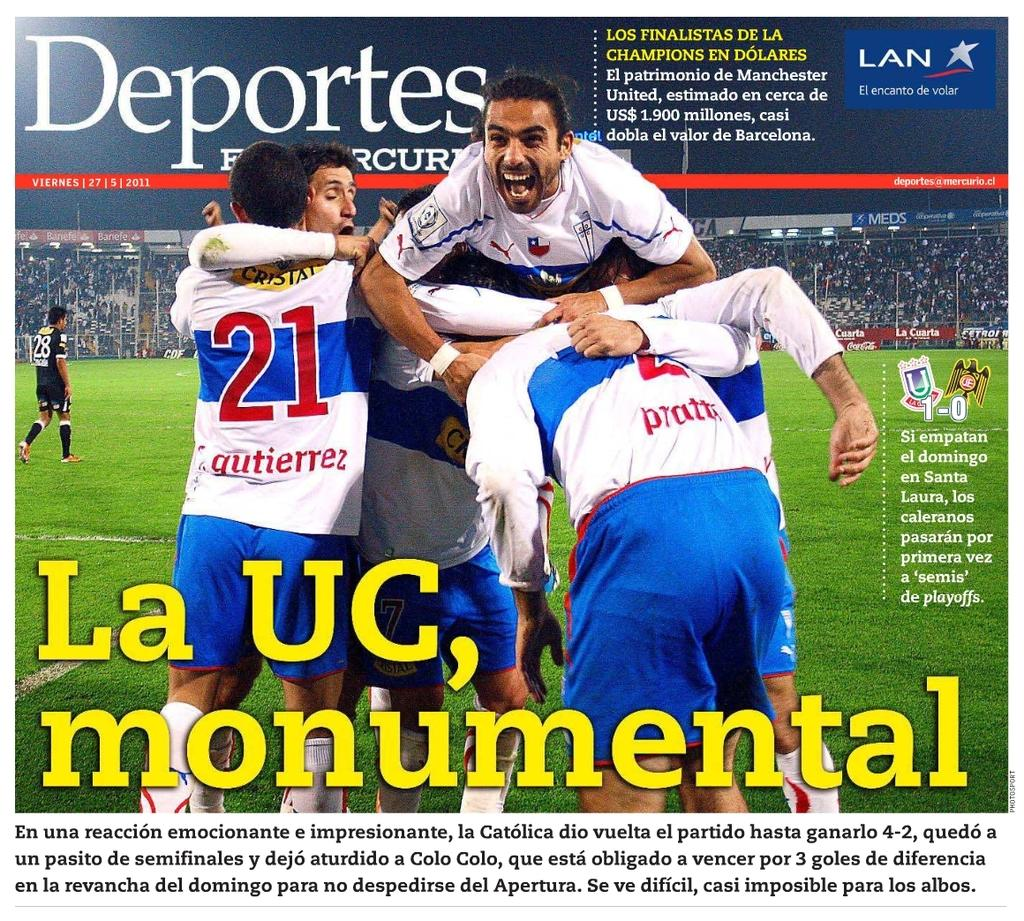<image>
Give a short and clear explanation of the subsequent image. La UC, monumental is the lead story of the Deportes publication. 